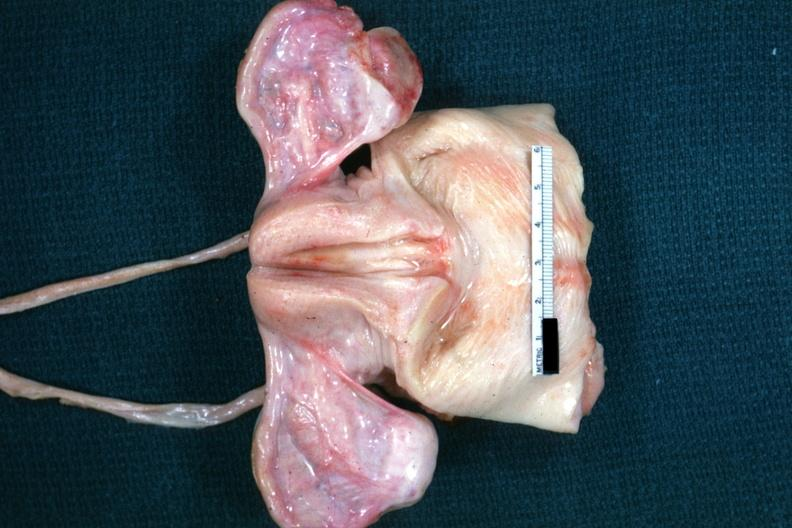what are truly normal ovaries of vacant sella but externally i can see nothing?
Answer the question using a single word or phrase. Non functional in this case 